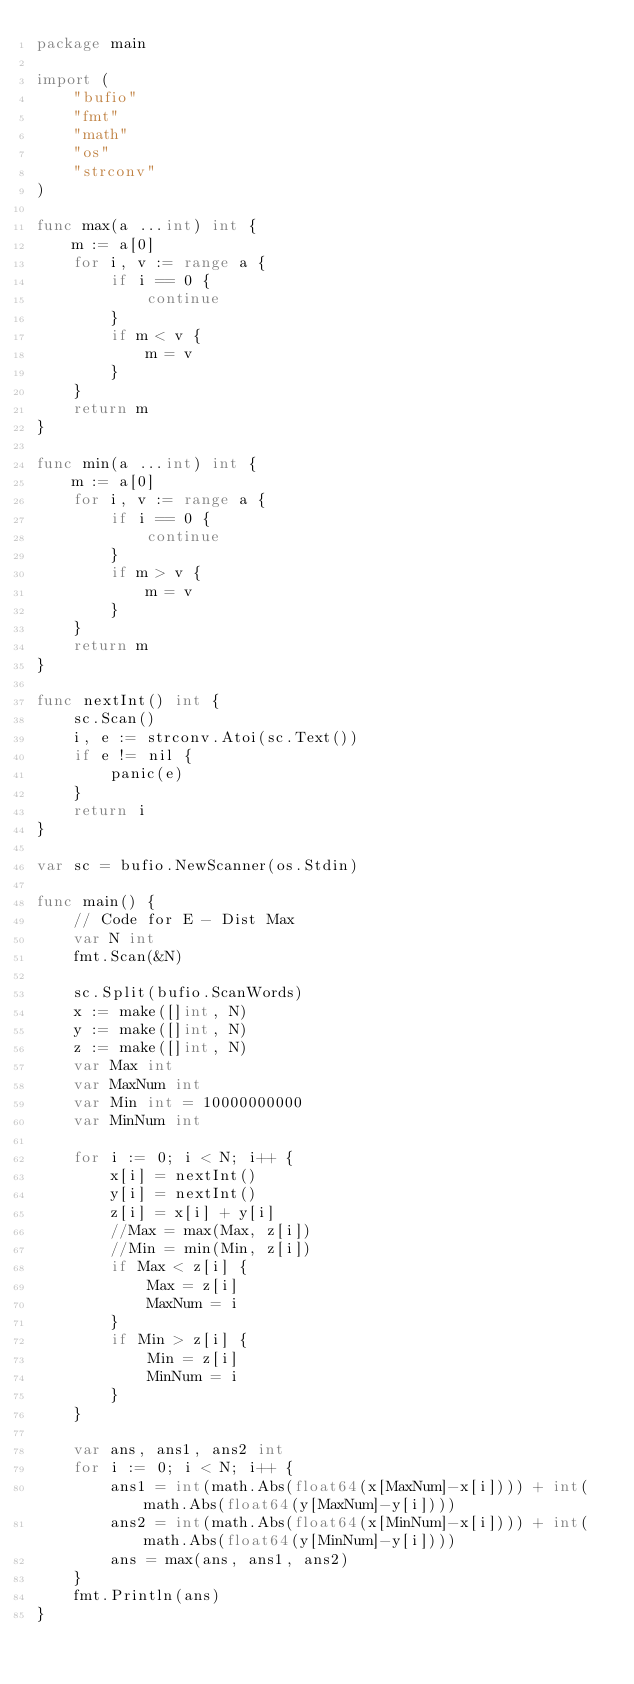<code> <loc_0><loc_0><loc_500><loc_500><_Go_>package main

import (
	"bufio"
	"fmt"
	"math"
	"os"
	"strconv"
)

func max(a ...int) int {
	m := a[0]
	for i, v := range a {
		if i == 0 {
			continue
		}
		if m < v {
			m = v
		}
	}
	return m
}

func min(a ...int) int {
	m := a[0]
	for i, v := range a {
		if i == 0 {
			continue
		}
		if m > v {
			m = v
		}
	}
	return m
}

func nextInt() int {
	sc.Scan()
	i, e := strconv.Atoi(sc.Text())
	if e != nil {
		panic(e)
	}
	return i
}

var sc = bufio.NewScanner(os.Stdin)

func main() {
	// Code for E - Dist Max
	var N int
	fmt.Scan(&N)

	sc.Split(bufio.ScanWords)
	x := make([]int, N)
	y := make([]int, N)
	z := make([]int, N)
	var Max int
	var MaxNum int
	var Min int = 10000000000
	var MinNum int

	for i := 0; i < N; i++ {
		x[i] = nextInt()
		y[i] = nextInt()
		z[i] = x[i] + y[i]
		//Max = max(Max, z[i])
		//Min = min(Min, z[i])
		if Max < z[i] {
			Max = z[i]
			MaxNum = i
		}
		if Min > z[i] {
			Min = z[i]
			MinNum = i
		}
	}

	var ans, ans1, ans2 int
	for i := 0; i < N; i++ {
		ans1 = int(math.Abs(float64(x[MaxNum]-x[i]))) + int(math.Abs(float64(y[MaxNum]-y[i])))
		ans2 = int(math.Abs(float64(x[MinNum]-x[i]))) + int(math.Abs(float64(y[MinNum]-y[i])))
		ans = max(ans, ans1, ans2)
	}
	fmt.Println(ans)
}
</code> 